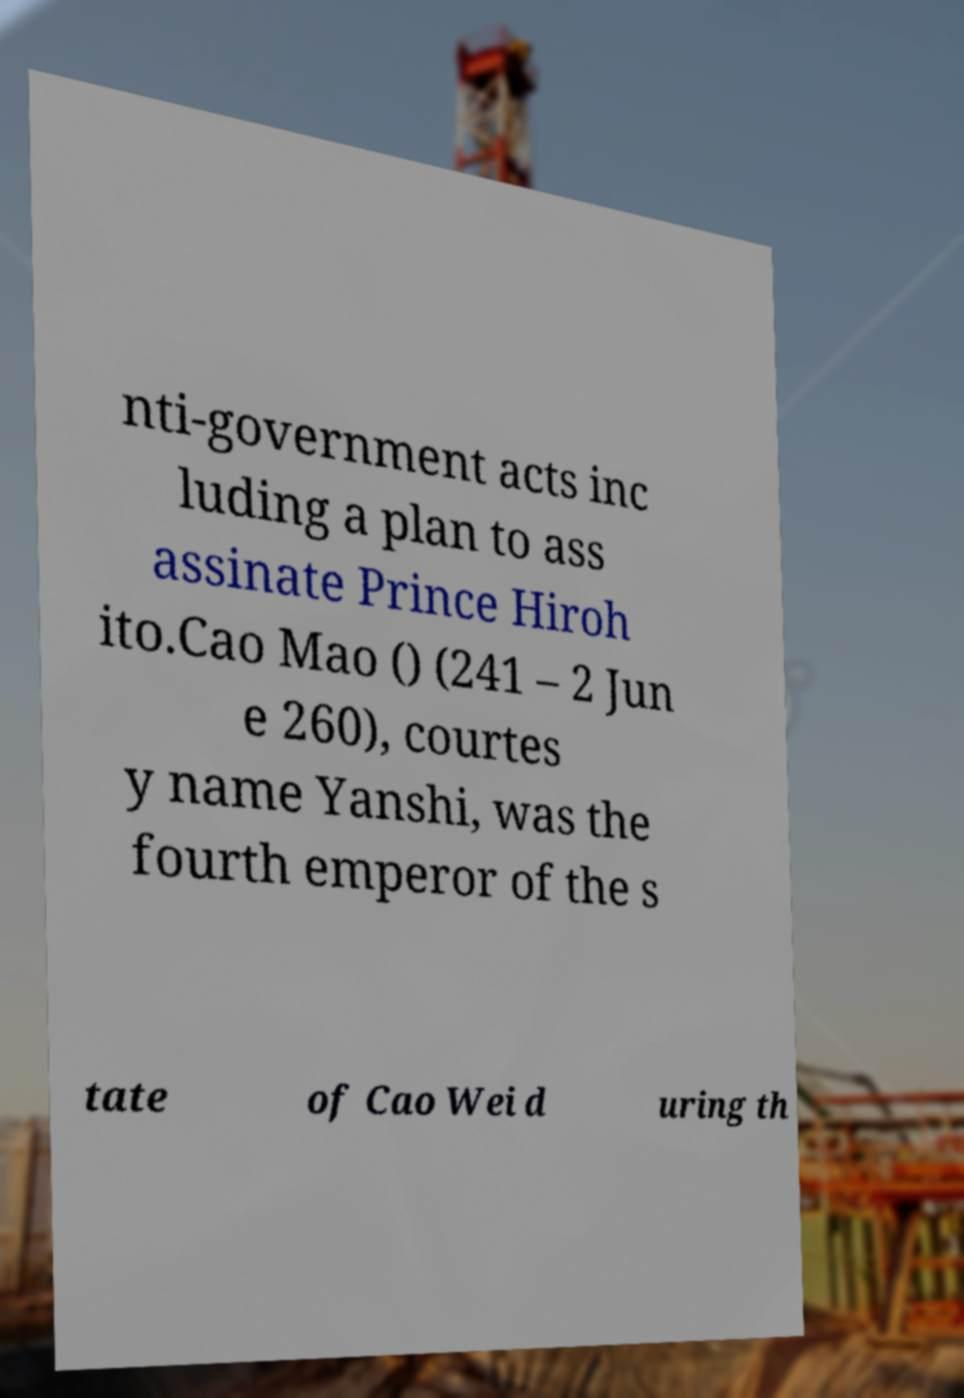Please read and relay the text visible in this image. What does it say? nti-government acts inc luding a plan to ass assinate Prince Hiroh ito.Cao Mao () (241 – 2 Jun e 260), courtes y name Yanshi, was the fourth emperor of the s tate of Cao Wei d uring th 